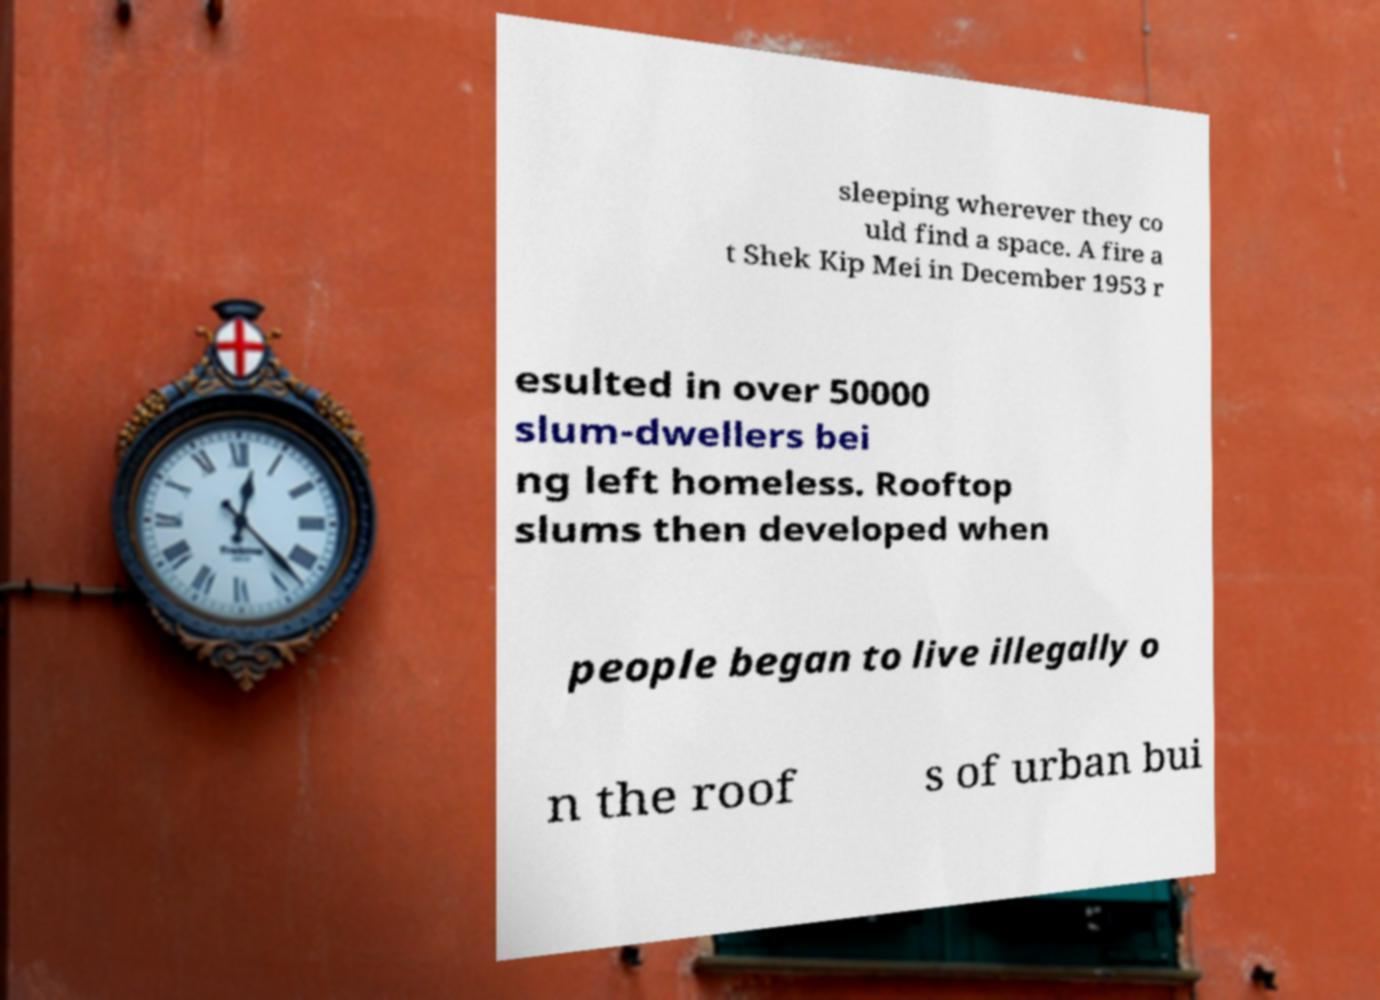Can you read and provide the text displayed in the image?This photo seems to have some interesting text. Can you extract and type it out for me? sleeping wherever they co uld find a space. A fire a t Shek Kip Mei in December 1953 r esulted in over 50000 slum-dwellers bei ng left homeless. Rooftop slums then developed when people began to live illegally o n the roof s of urban bui 